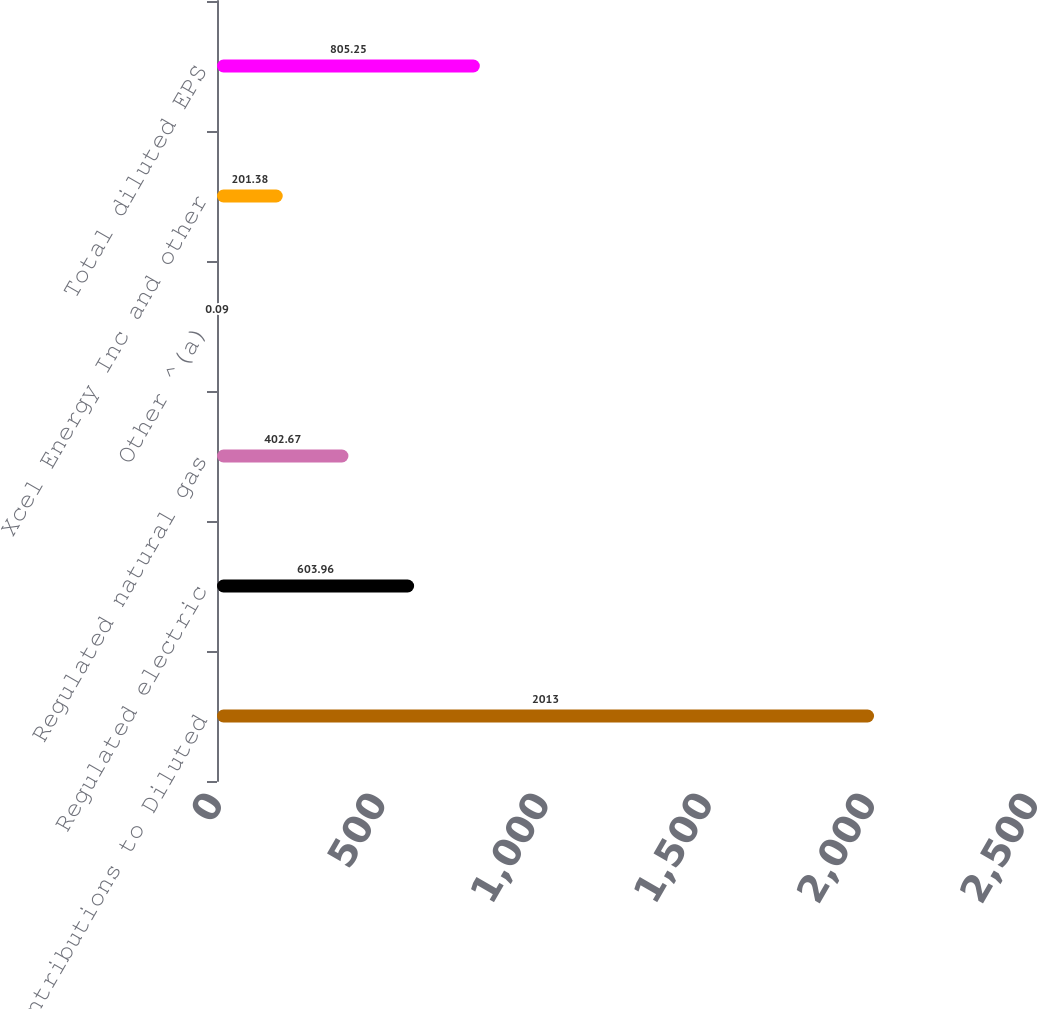<chart> <loc_0><loc_0><loc_500><loc_500><bar_chart><fcel>Contributions to Diluted<fcel>Regulated electric<fcel>Regulated natural gas<fcel>Other ^(a)<fcel>Xcel Energy Inc and other<fcel>Total diluted EPS<nl><fcel>2013<fcel>603.96<fcel>402.67<fcel>0.09<fcel>201.38<fcel>805.25<nl></chart> 